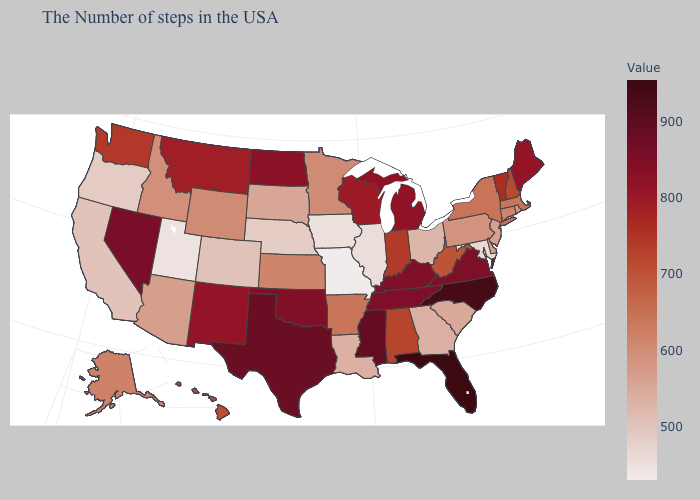Does Florida have the highest value in the USA?
Keep it brief. Yes. Is the legend a continuous bar?
Concise answer only. Yes. Which states have the lowest value in the MidWest?
Answer briefly. Missouri. 